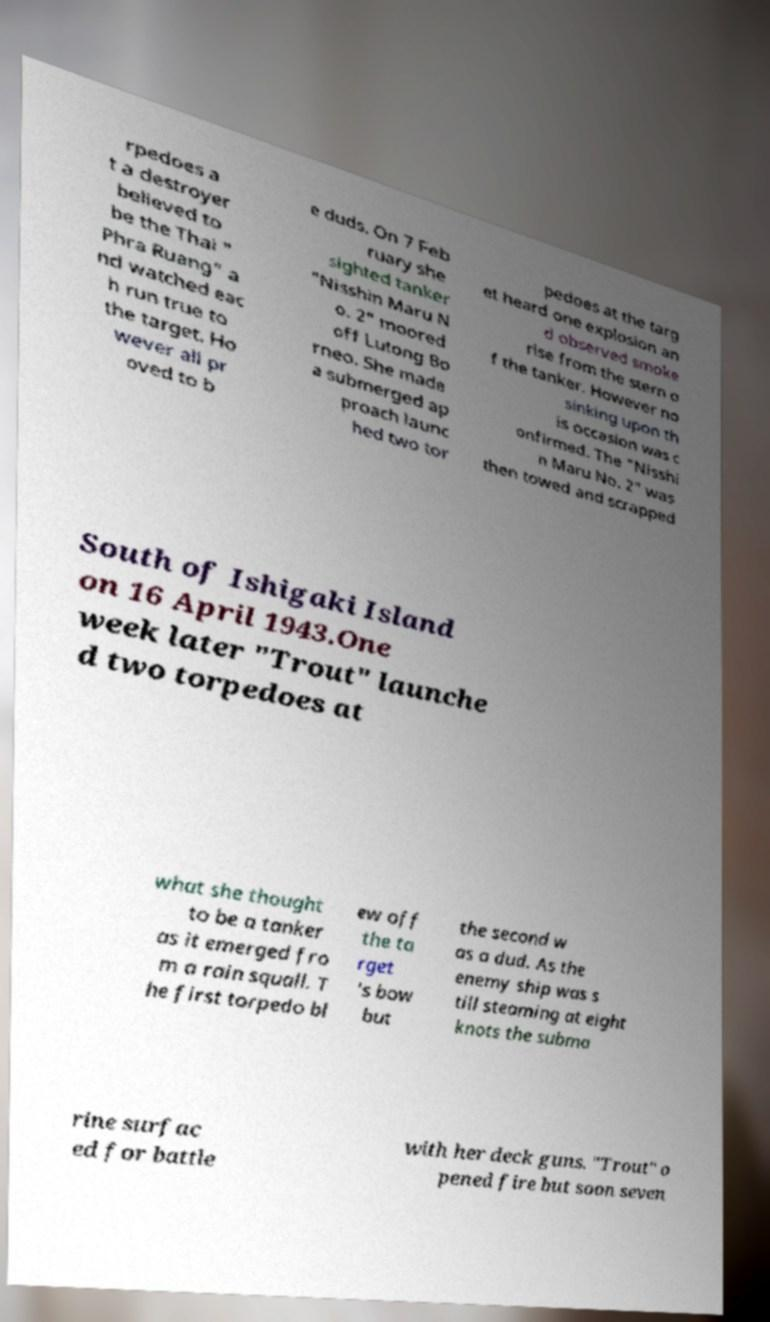What messages or text are displayed in this image? I need them in a readable, typed format. rpedoes a t a destroyer believed to be the Thai " Phra Ruang" a nd watched eac h run true to the target. Ho wever all pr oved to b e duds. On 7 Feb ruary she sighted tanker "Nisshin Maru N o. 2" moored off Lutong Bo rneo. She made a submerged ap proach launc hed two tor pedoes at the targ et heard one explosion an d observed smoke rise from the stern o f the tanker. However no sinking upon th is occasion was c onfirmed. The "Nisshi n Maru No. 2" was then towed and scrapped South of Ishigaki Island on 16 April 1943.One week later "Trout" launche d two torpedoes at what she thought to be a tanker as it emerged fro m a rain squall. T he first torpedo bl ew off the ta rget 's bow but the second w as a dud. As the enemy ship was s till steaming at eight knots the subma rine surfac ed for battle with her deck guns. "Trout" o pened fire but soon seven 